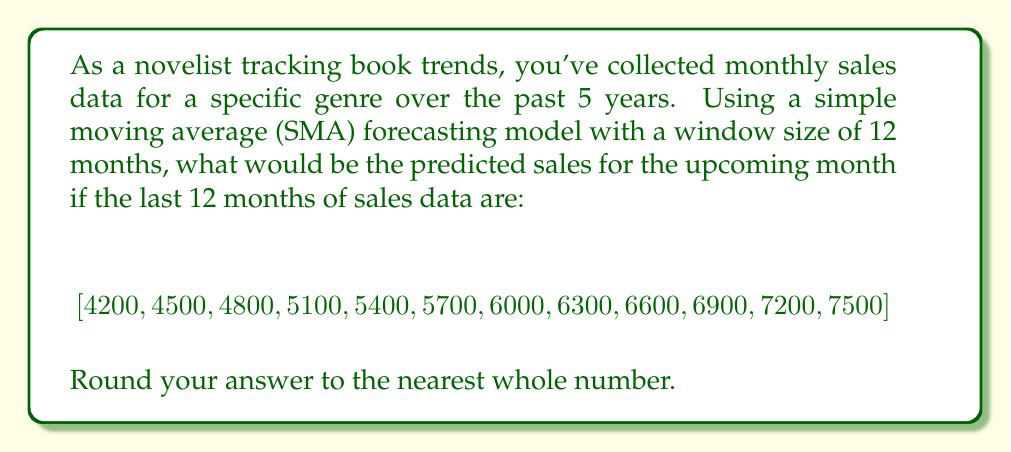Solve this math problem. To solve this problem, we'll use the simple moving average (SMA) forecasting model, which is a basic time series analysis technique. The SMA calculates the arithmetic mean of a given set of values over a specified period.

The formula for SMA is:

$$SMA = \frac{\sum_{i=1}^{n} x_i}{n}$$

Where:
$x_i$ represents each value in the dataset
$n$ is the number of periods (window size)

In this case, we have:
$n = 12$ (12-month window)
$x_i$ are the sales figures for each month

Let's calculate the SMA:

1. Sum up all the values:
   $4200 + 4500 + 4800 + 5100 + 5400 + 5700 + 6000 + 6300 + 6600 + 6900 + 7200 + 7500 = 70200$

2. Divide the sum by the number of periods (12):
   $$SMA = \frac{70200}{12} = 5850$$

3. Round to the nearest whole number:
   $5850$ rounded to the nearest whole number is $5850$.

This value represents the predicted sales for the upcoming month based on the SMA model.
Answer: 5850 